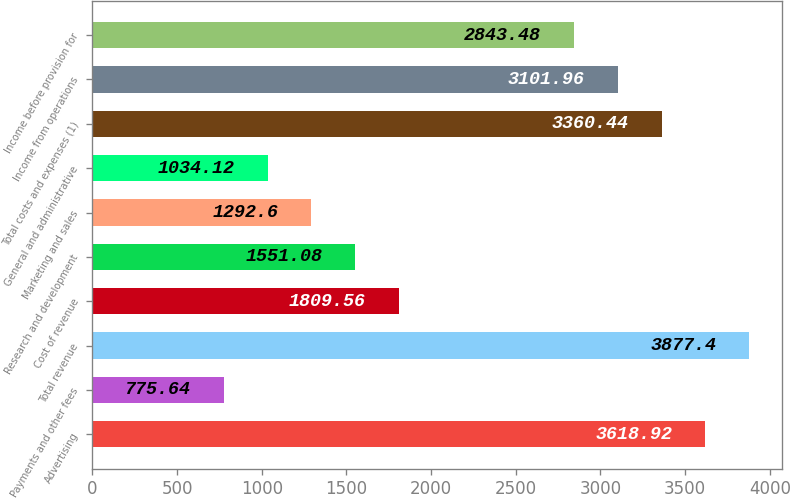Convert chart to OTSL. <chart><loc_0><loc_0><loc_500><loc_500><bar_chart><fcel>Advertising<fcel>Payments and other fees<fcel>Total revenue<fcel>Cost of revenue<fcel>Research and development<fcel>Marketing and sales<fcel>General and administrative<fcel>Total costs and expenses (1)<fcel>Income from operations<fcel>Income before provision for<nl><fcel>3618.92<fcel>775.64<fcel>3877.4<fcel>1809.56<fcel>1551.08<fcel>1292.6<fcel>1034.12<fcel>3360.44<fcel>3101.96<fcel>2843.48<nl></chart> 